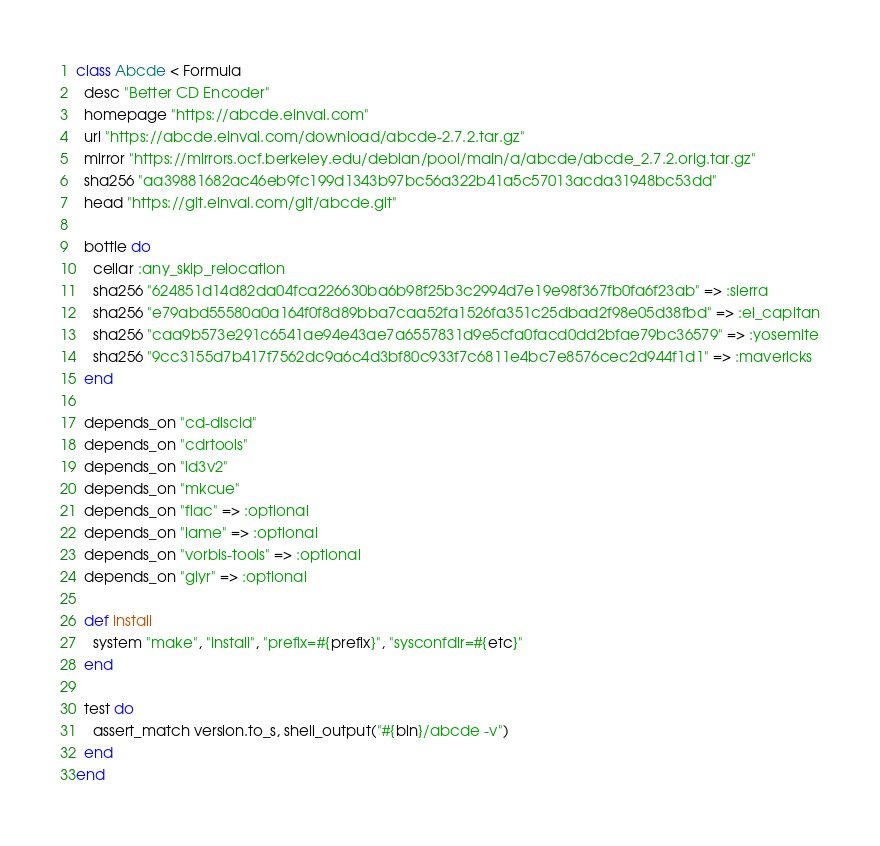Convert code to text. <code><loc_0><loc_0><loc_500><loc_500><_Ruby_>class Abcde < Formula
  desc "Better CD Encoder"
  homepage "https://abcde.einval.com"
  url "https://abcde.einval.com/download/abcde-2.7.2.tar.gz"
  mirror "https://mirrors.ocf.berkeley.edu/debian/pool/main/a/abcde/abcde_2.7.2.orig.tar.gz"
  sha256 "aa39881682ac46eb9fc199d1343b97bc56a322b41a5c57013acda31948bc53dd"
  head "https://git.einval.com/git/abcde.git"

  bottle do
    cellar :any_skip_relocation
    sha256 "624851d14d82da04fca226630ba6b98f25b3c2994d7e19e98f367fb0fa6f23ab" => :sierra
    sha256 "e79abd55580a0a164f0f8d89bba7caa52fa1526fa351c25dbad2f98e05d38fbd" => :el_capitan
    sha256 "caa9b573e291c6541ae94e43ae7a6557831d9e5cfa0facd0dd2bfae79bc36579" => :yosemite
    sha256 "9cc3155d7b417f7562dc9a6c4d3bf80c933f7c6811e4bc7e8576cec2d944f1d1" => :mavericks
  end

  depends_on "cd-discid"
  depends_on "cdrtools"
  depends_on "id3v2"
  depends_on "mkcue"
  depends_on "flac" => :optional
  depends_on "lame" => :optional
  depends_on "vorbis-tools" => :optional
  depends_on "glyr" => :optional

  def install
    system "make", "install", "prefix=#{prefix}", "sysconfdir=#{etc}"
  end

  test do
    assert_match version.to_s, shell_output("#{bin}/abcde -v")
  end
end
</code> 